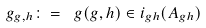Convert formula to latex. <formula><loc_0><loc_0><loc_500><loc_500>\ g _ { g , h } \colon = \ g ( g , h ) \in i _ { g h } ( A _ { g h } )</formula> 